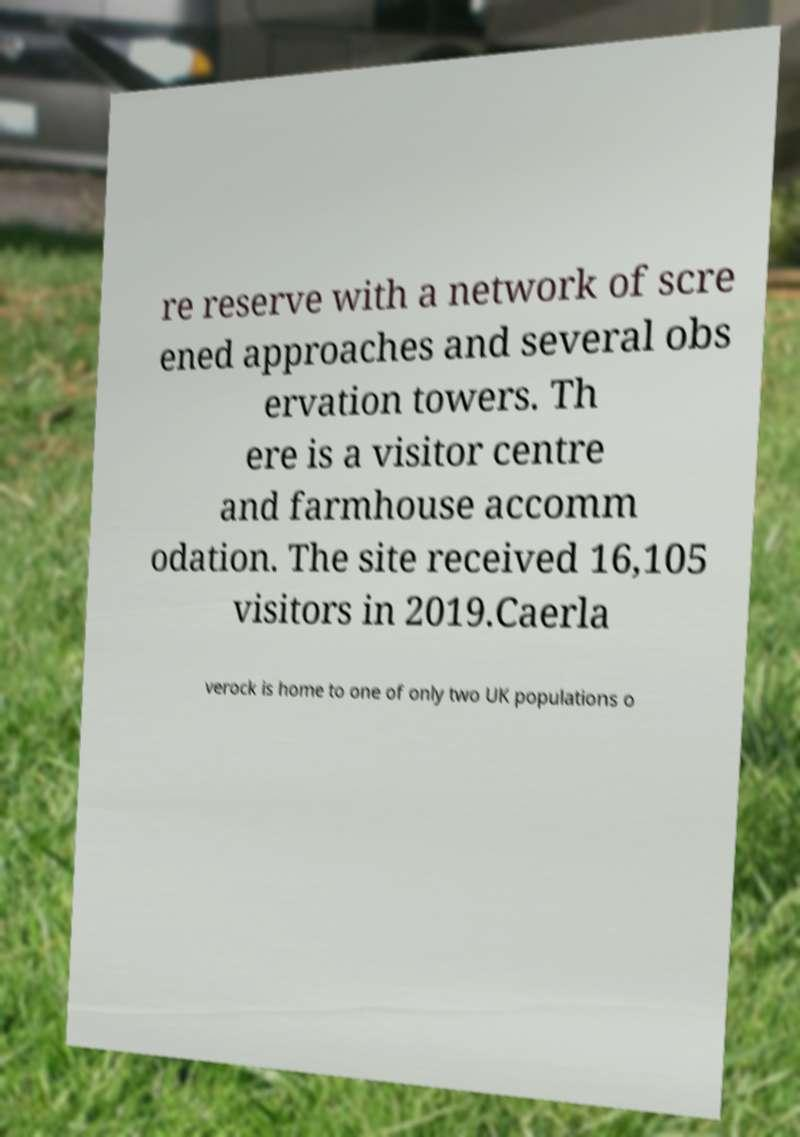I need the written content from this picture converted into text. Can you do that? re reserve with a network of scre ened approaches and several obs ervation towers. Th ere is a visitor centre and farmhouse accomm odation. The site received 16,105 visitors in 2019.Caerla verock is home to one of only two UK populations o 